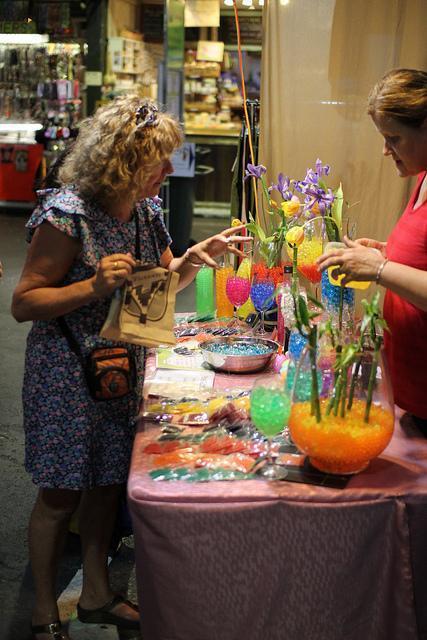How many women appear in the picture?
Give a very brief answer. 2. How many bowls are in the photo?
Give a very brief answer. 2. How many people are there?
Give a very brief answer. 2. How many handbags are in the photo?
Give a very brief answer. 2. How many people are at the train stop?
Give a very brief answer. 0. 